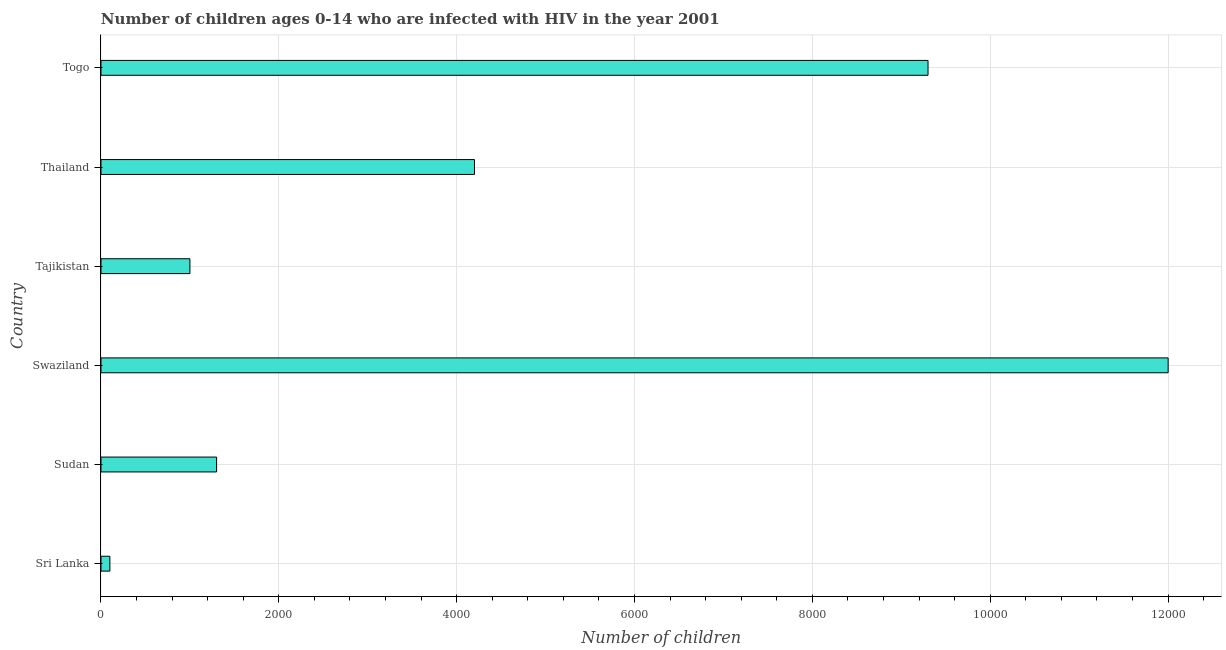Does the graph contain any zero values?
Offer a very short reply. No. What is the title of the graph?
Your response must be concise. Number of children ages 0-14 who are infected with HIV in the year 2001. What is the label or title of the X-axis?
Your answer should be compact. Number of children. What is the number of children living with hiv in Swaziland?
Keep it short and to the point. 1.20e+04. Across all countries, what is the maximum number of children living with hiv?
Your answer should be very brief. 1.20e+04. In which country was the number of children living with hiv maximum?
Offer a very short reply. Swaziland. In which country was the number of children living with hiv minimum?
Keep it short and to the point. Sri Lanka. What is the sum of the number of children living with hiv?
Offer a very short reply. 2.79e+04. What is the difference between the number of children living with hiv in Sri Lanka and Thailand?
Provide a succinct answer. -4100. What is the average number of children living with hiv per country?
Make the answer very short. 4650. What is the median number of children living with hiv?
Provide a short and direct response. 2750. In how many countries, is the number of children living with hiv greater than 1600 ?
Provide a short and direct response. 3. What is the ratio of the number of children living with hiv in Tajikistan to that in Thailand?
Your answer should be compact. 0.24. Is the difference between the number of children living with hiv in Sri Lanka and Togo greater than the difference between any two countries?
Your response must be concise. No. What is the difference between the highest and the second highest number of children living with hiv?
Give a very brief answer. 2700. What is the difference between the highest and the lowest number of children living with hiv?
Your answer should be very brief. 1.19e+04. What is the Number of children in Sudan?
Your answer should be very brief. 1300. What is the Number of children of Swaziland?
Ensure brevity in your answer.  1.20e+04. What is the Number of children in Tajikistan?
Keep it short and to the point. 1000. What is the Number of children in Thailand?
Offer a terse response. 4200. What is the Number of children of Togo?
Offer a terse response. 9300. What is the difference between the Number of children in Sri Lanka and Sudan?
Your answer should be compact. -1200. What is the difference between the Number of children in Sri Lanka and Swaziland?
Your answer should be compact. -1.19e+04. What is the difference between the Number of children in Sri Lanka and Tajikistan?
Make the answer very short. -900. What is the difference between the Number of children in Sri Lanka and Thailand?
Your response must be concise. -4100. What is the difference between the Number of children in Sri Lanka and Togo?
Provide a short and direct response. -9200. What is the difference between the Number of children in Sudan and Swaziland?
Give a very brief answer. -1.07e+04. What is the difference between the Number of children in Sudan and Tajikistan?
Ensure brevity in your answer.  300. What is the difference between the Number of children in Sudan and Thailand?
Your answer should be compact. -2900. What is the difference between the Number of children in Sudan and Togo?
Offer a very short reply. -8000. What is the difference between the Number of children in Swaziland and Tajikistan?
Make the answer very short. 1.10e+04. What is the difference between the Number of children in Swaziland and Thailand?
Your answer should be compact. 7800. What is the difference between the Number of children in Swaziland and Togo?
Keep it short and to the point. 2700. What is the difference between the Number of children in Tajikistan and Thailand?
Offer a terse response. -3200. What is the difference between the Number of children in Tajikistan and Togo?
Your answer should be very brief. -8300. What is the difference between the Number of children in Thailand and Togo?
Provide a succinct answer. -5100. What is the ratio of the Number of children in Sri Lanka to that in Sudan?
Your response must be concise. 0.08. What is the ratio of the Number of children in Sri Lanka to that in Swaziland?
Make the answer very short. 0.01. What is the ratio of the Number of children in Sri Lanka to that in Tajikistan?
Offer a terse response. 0.1. What is the ratio of the Number of children in Sri Lanka to that in Thailand?
Offer a terse response. 0.02. What is the ratio of the Number of children in Sri Lanka to that in Togo?
Offer a very short reply. 0.01. What is the ratio of the Number of children in Sudan to that in Swaziland?
Offer a very short reply. 0.11. What is the ratio of the Number of children in Sudan to that in Tajikistan?
Keep it short and to the point. 1.3. What is the ratio of the Number of children in Sudan to that in Thailand?
Your response must be concise. 0.31. What is the ratio of the Number of children in Sudan to that in Togo?
Give a very brief answer. 0.14. What is the ratio of the Number of children in Swaziland to that in Thailand?
Offer a terse response. 2.86. What is the ratio of the Number of children in Swaziland to that in Togo?
Offer a terse response. 1.29. What is the ratio of the Number of children in Tajikistan to that in Thailand?
Your answer should be compact. 0.24. What is the ratio of the Number of children in Tajikistan to that in Togo?
Make the answer very short. 0.11. What is the ratio of the Number of children in Thailand to that in Togo?
Your answer should be very brief. 0.45. 